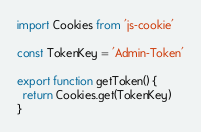<code> <loc_0><loc_0><loc_500><loc_500><_JavaScript_>import Cookies from 'js-cookie'

const TokenKey = 'Admin-Token'

export function getToken() {
  return Cookies.get(TokenKey)
}
</code> 